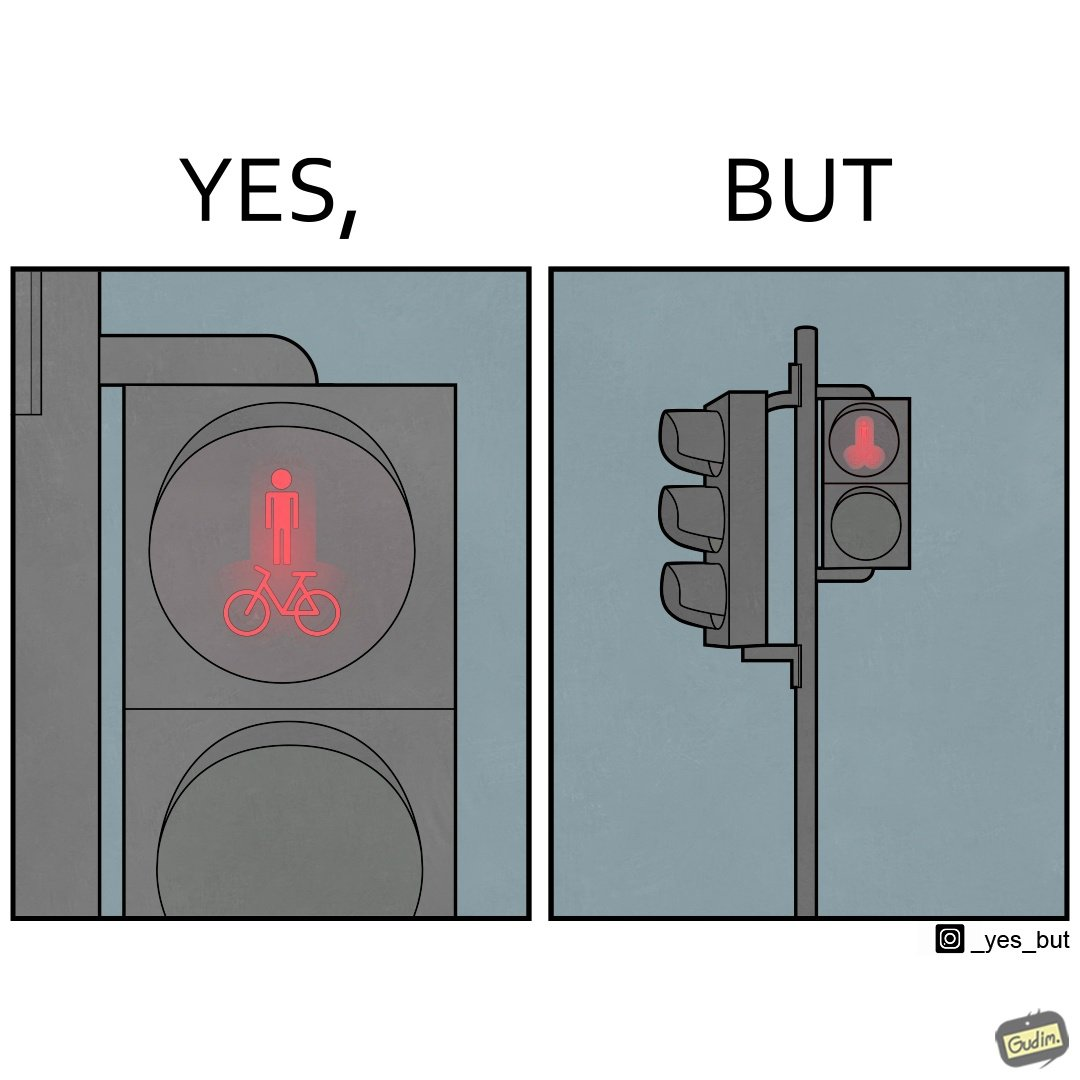Describe the content of this image. This image is funny because images of very regular things - a stick figure and a bicycle, get converted into  looking phallic from a distance. 